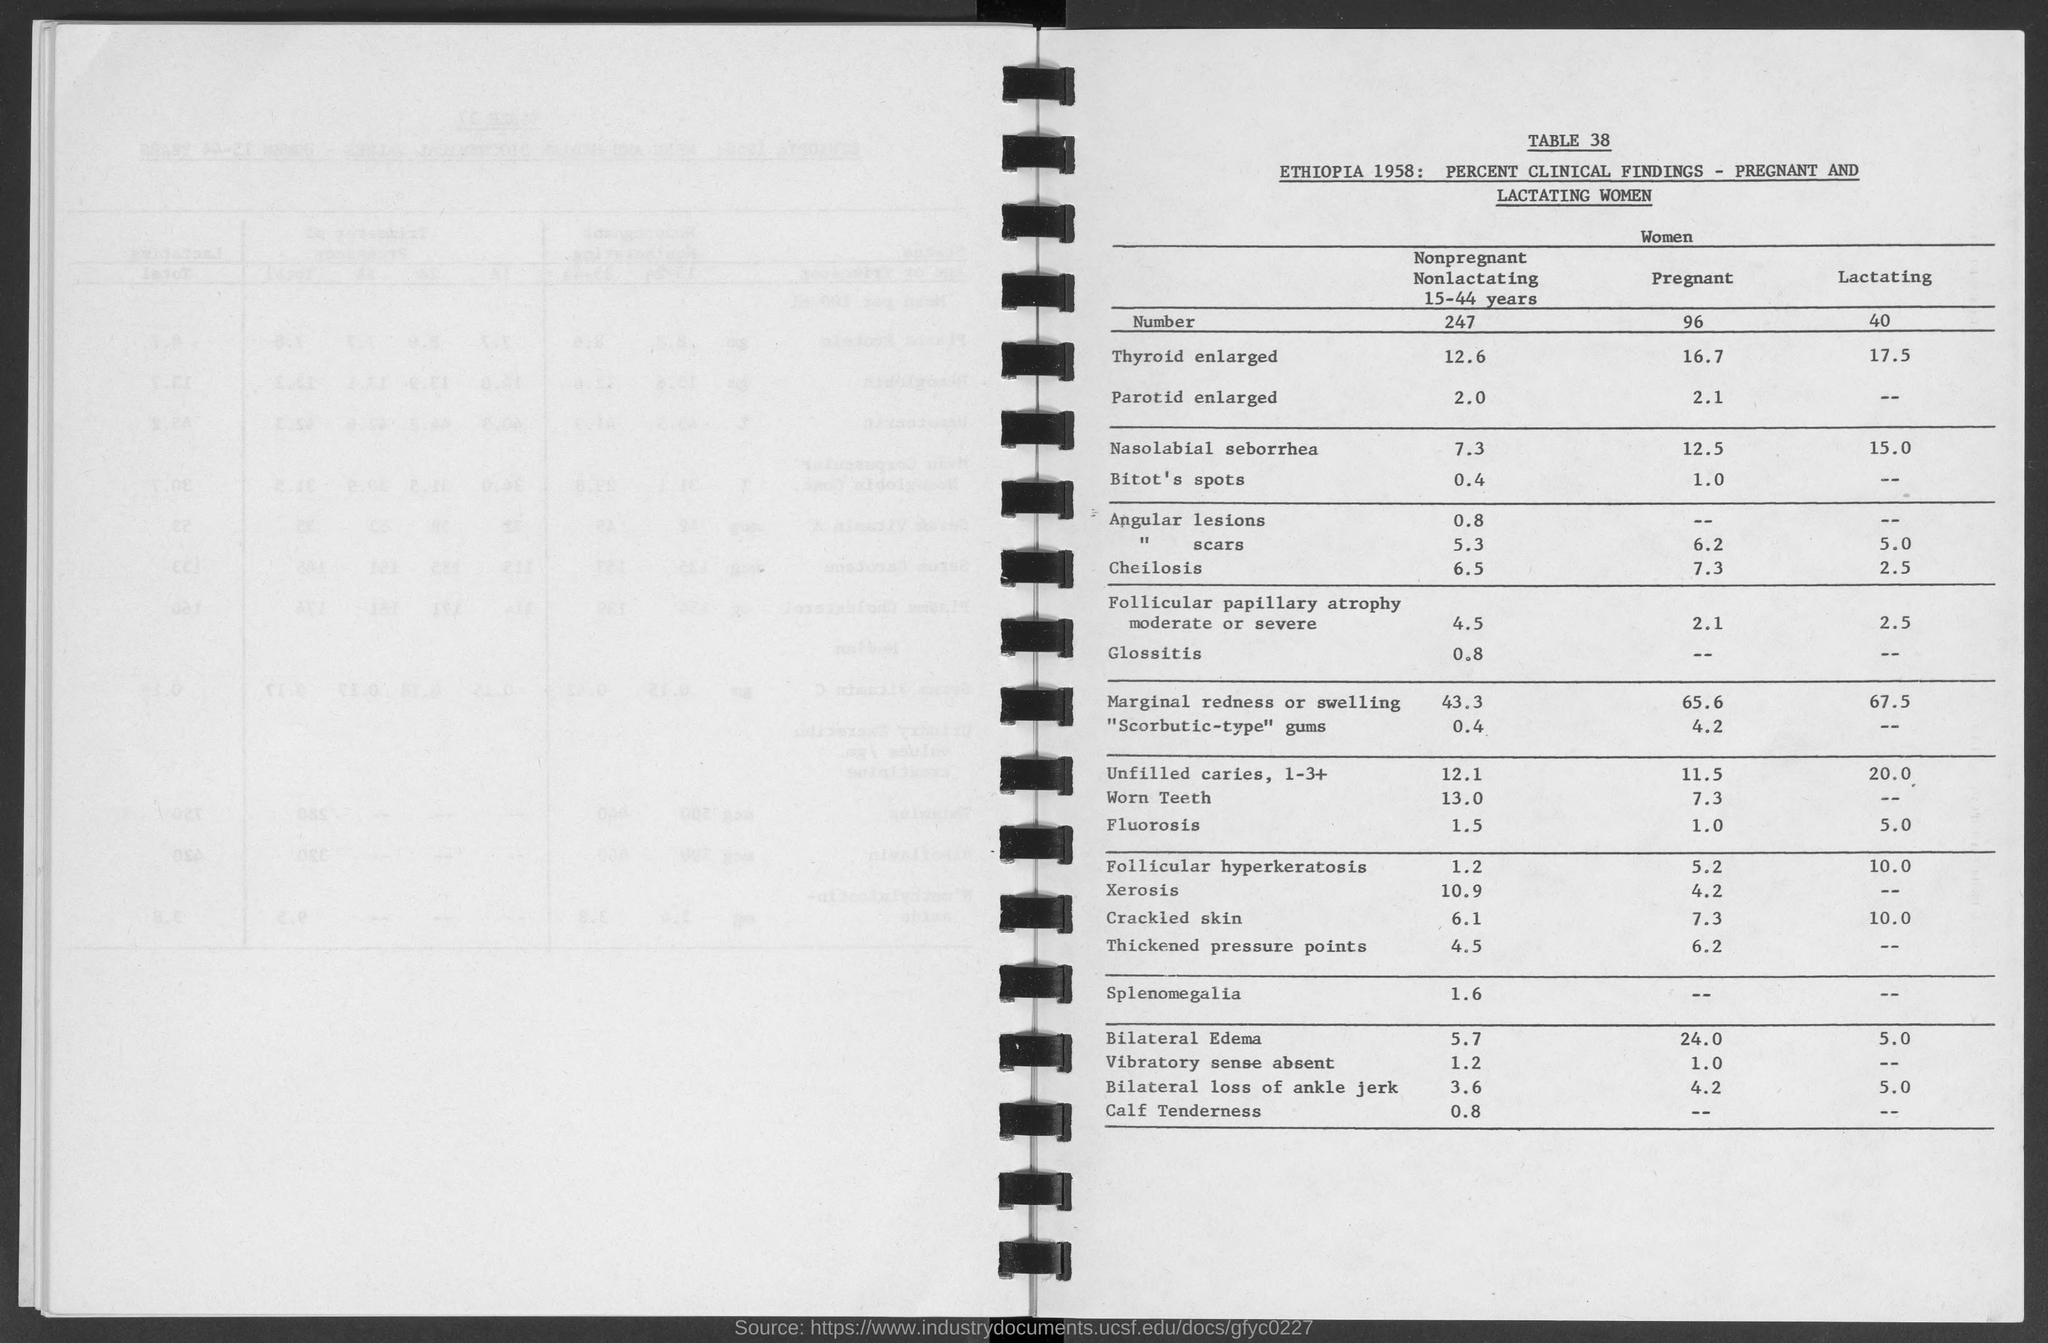What is the table no. ?
Ensure brevity in your answer.  38. 